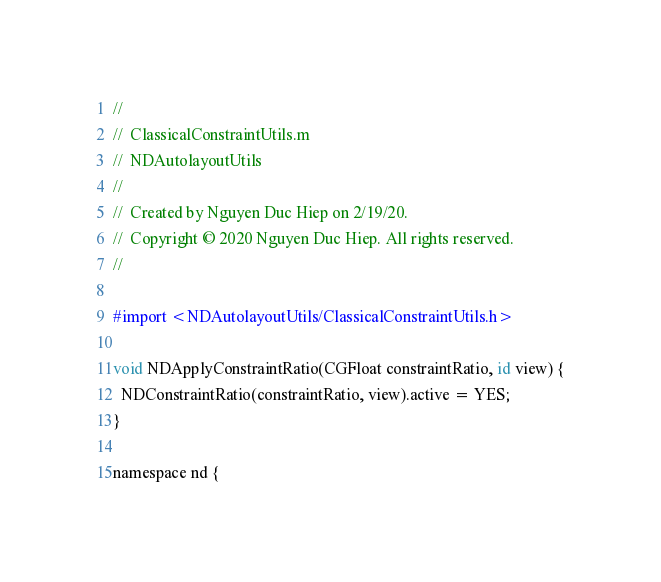<code> <loc_0><loc_0><loc_500><loc_500><_ObjectiveC_>//
//  ClassicalConstraintUtils.m
//  NDAutolayoutUtils
//
//  Created by Nguyen Duc Hiep on 2/19/20.
//  Copyright © 2020 Nguyen Duc Hiep. All rights reserved.
//

#import <NDAutolayoutUtils/ClassicalConstraintUtils.h>

void NDApplyConstraintRatio(CGFloat constraintRatio, id view) {
  NDConstraintRatio(constraintRatio, view).active = YES;
}

namespace nd {</code> 